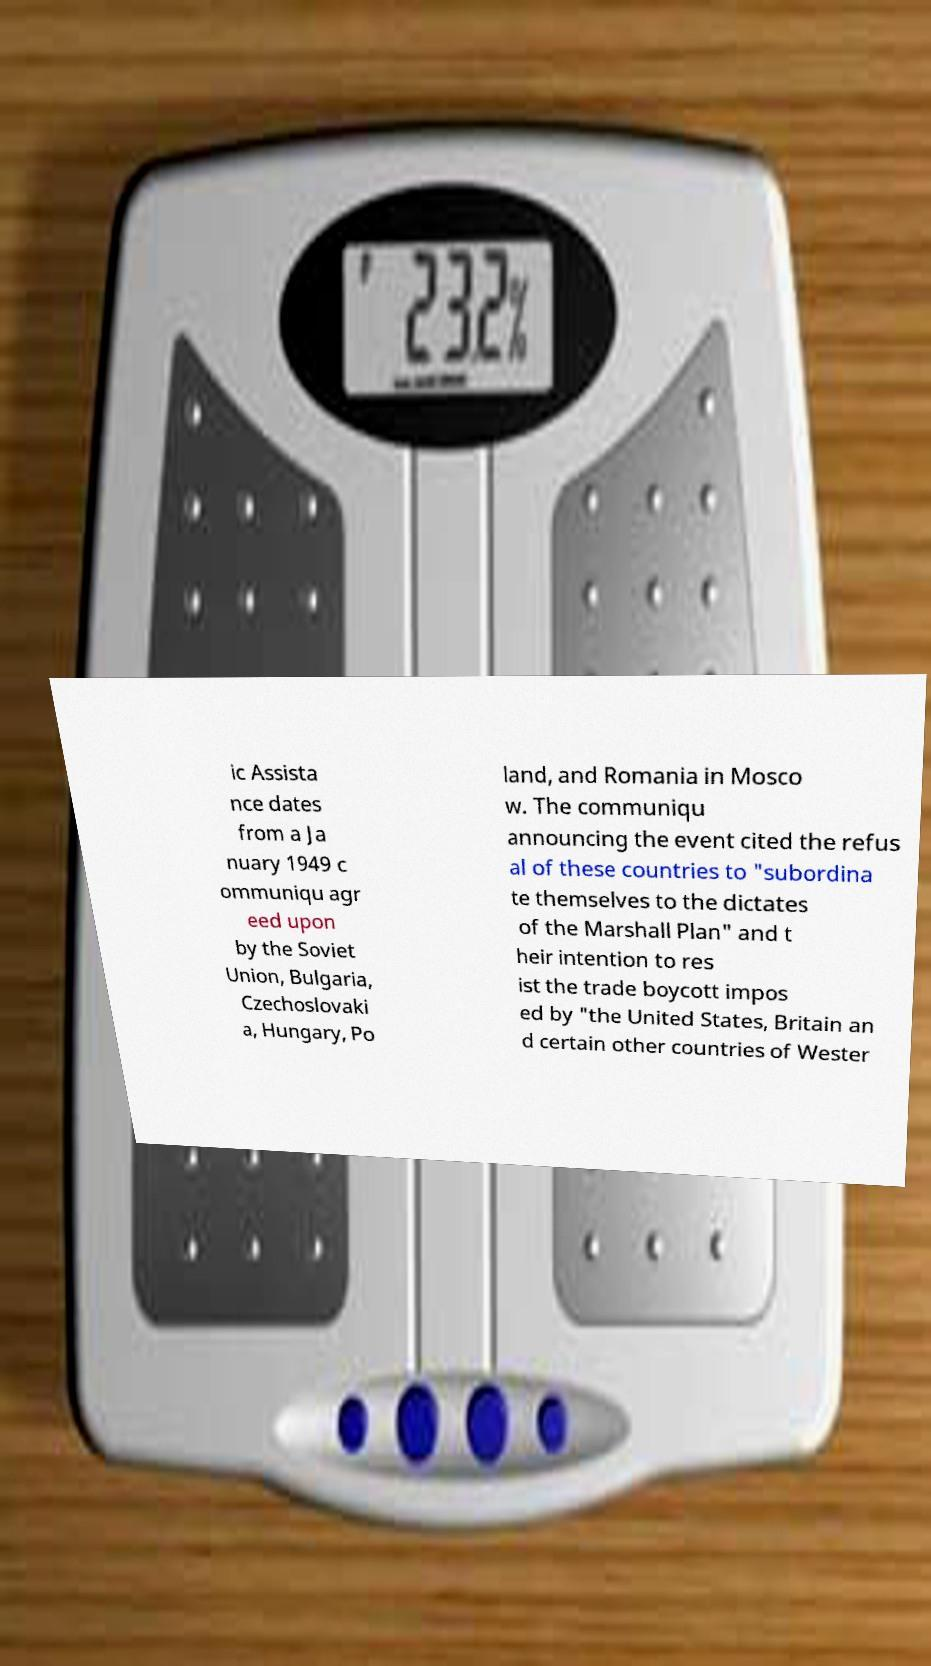Can you read and provide the text displayed in the image?This photo seems to have some interesting text. Can you extract and type it out for me? ic Assista nce dates from a Ja nuary 1949 c ommuniqu agr eed upon by the Soviet Union, Bulgaria, Czechoslovaki a, Hungary, Po land, and Romania in Mosco w. The communiqu announcing the event cited the refus al of these countries to "subordina te themselves to the dictates of the Marshall Plan" and t heir intention to res ist the trade boycott impos ed by "the United States, Britain an d certain other countries of Wester 